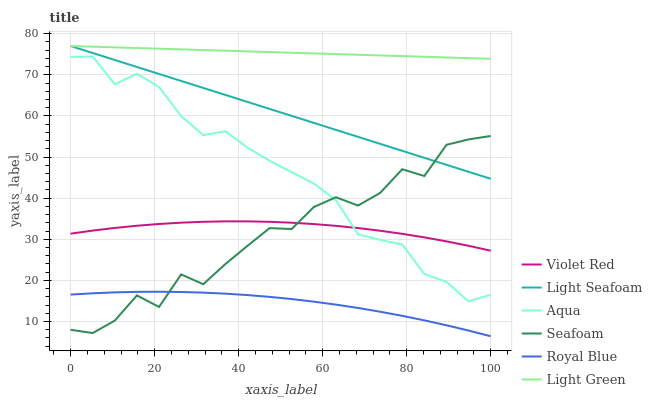Does Royal Blue have the minimum area under the curve?
Answer yes or no. Yes. Does Light Green have the maximum area under the curve?
Answer yes or no. Yes. Does Aqua have the minimum area under the curve?
Answer yes or no. No. Does Aqua have the maximum area under the curve?
Answer yes or no. No. Is Light Green the smoothest?
Answer yes or no. Yes. Is Seafoam the roughest?
Answer yes or no. Yes. Is Aqua the smoothest?
Answer yes or no. No. Is Aqua the roughest?
Answer yes or no. No. Does Royal Blue have the lowest value?
Answer yes or no. Yes. Does Aqua have the lowest value?
Answer yes or no. No. Does Light Seafoam have the highest value?
Answer yes or no. Yes. Does Aqua have the highest value?
Answer yes or no. No. Is Aqua less than Light Seafoam?
Answer yes or no. Yes. Is Aqua greater than Royal Blue?
Answer yes or no. Yes. Does Light Seafoam intersect Light Green?
Answer yes or no. Yes. Is Light Seafoam less than Light Green?
Answer yes or no. No. Is Light Seafoam greater than Light Green?
Answer yes or no. No. Does Aqua intersect Light Seafoam?
Answer yes or no. No. 